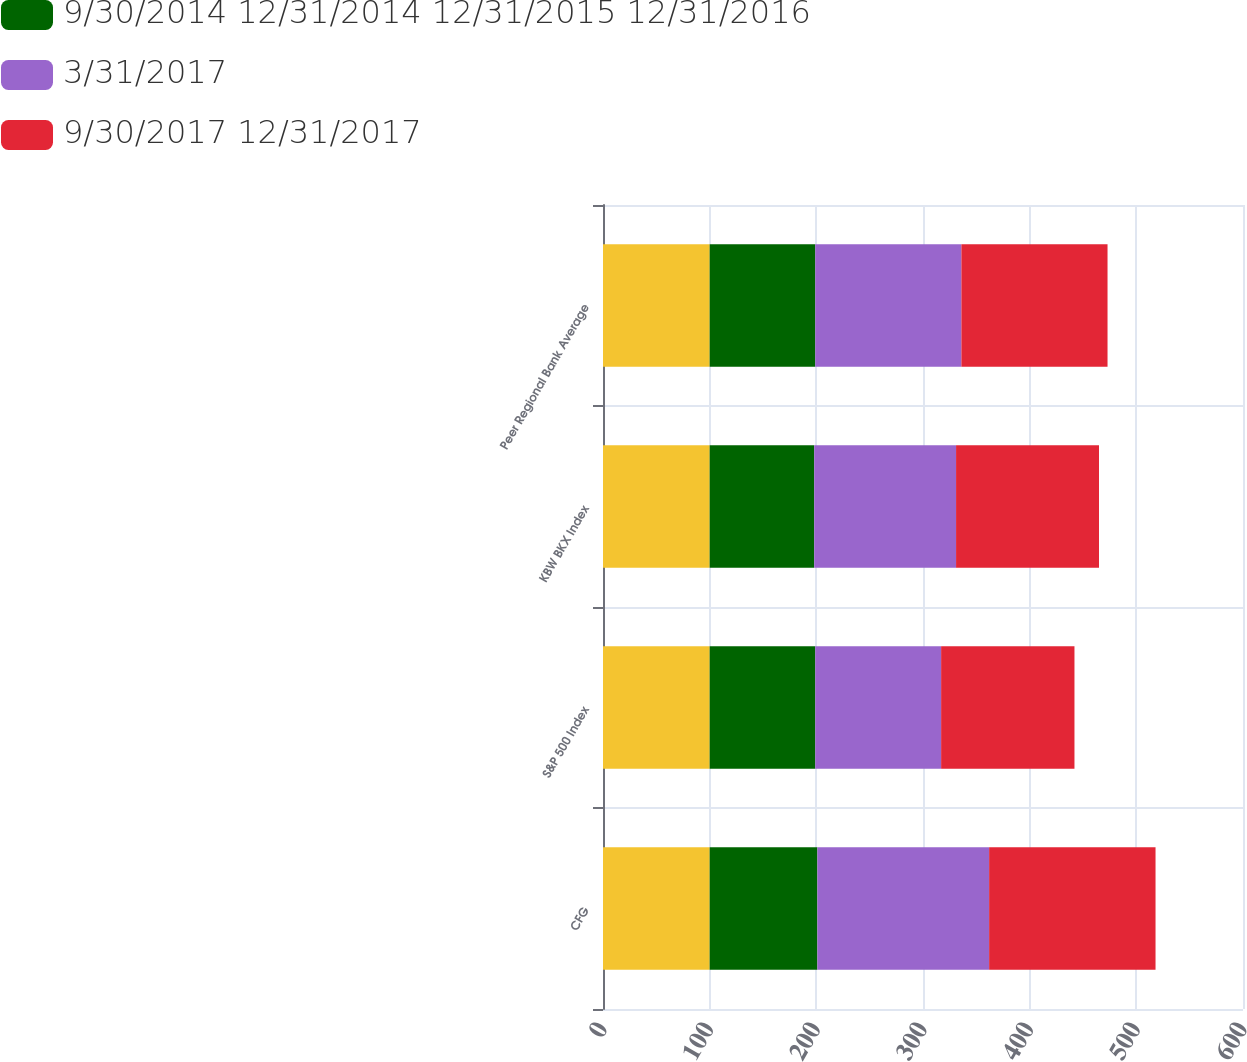Convert chart. <chart><loc_0><loc_0><loc_500><loc_500><stacked_bar_chart><ecel><fcel>CFG<fcel>S&P 500 Index<fcel>KBW BKX Index<fcel>Peer Regional Bank Average<nl><fcel>nan<fcel>100<fcel>100<fcel>100<fcel>100<nl><fcel>9/30/2014 12/31/2014 12/31/2015 12/31/2016<fcel>101<fcel>99<fcel>98<fcel>99<nl><fcel>3/31/2017<fcel>161<fcel>118<fcel>133<fcel>137<nl><fcel>9/30/2017 12/31/2017<fcel>156<fcel>125<fcel>134<fcel>137<nl></chart> 